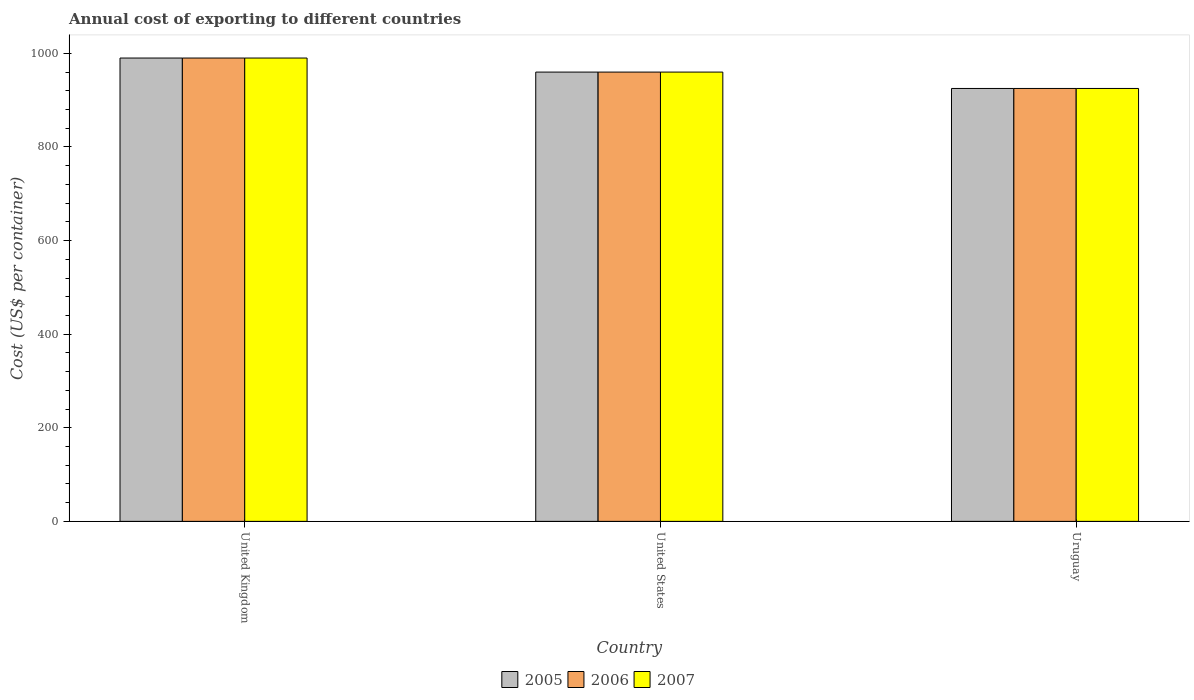How many groups of bars are there?
Offer a very short reply. 3. Are the number of bars per tick equal to the number of legend labels?
Keep it short and to the point. Yes. Are the number of bars on each tick of the X-axis equal?
Provide a short and direct response. Yes. How many bars are there on the 2nd tick from the left?
Make the answer very short. 3. How many bars are there on the 2nd tick from the right?
Your answer should be very brief. 3. What is the label of the 2nd group of bars from the left?
Give a very brief answer. United States. What is the total annual cost of exporting in 2006 in United Kingdom?
Give a very brief answer. 990. Across all countries, what is the maximum total annual cost of exporting in 2007?
Keep it short and to the point. 990. Across all countries, what is the minimum total annual cost of exporting in 2005?
Offer a terse response. 925. In which country was the total annual cost of exporting in 2007 minimum?
Offer a very short reply. Uruguay. What is the total total annual cost of exporting in 2005 in the graph?
Ensure brevity in your answer.  2875. What is the difference between the total annual cost of exporting in 2007 in United Kingdom and that in Uruguay?
Provide a succinct answer. 65. What is the difference between the total annual cost of exporting in 2007 in United States and the total annual cost of exporting in 2005 in United Kingdom?
Give a very brief answer. -30. What is the average total annual cost of exporting in 2005 per country?
Your answer should be compact. 958.33. What is the difference between the total annual cost of exporting of/in 2006 and total annual cost of exporting of/in 2005 in United Kingdom?
Your answer should be very brief. 0. What is the ratio of the total annual cost of exporting in 2006 in United Kingdom to that in United States?
Your answer should be very brief. 1.03. What is the difference between the highest and the second highest total annual cost of exporting in 2005?
Offer a terse response. 35. What is the difference between the highest and the lowest total annual cost of exporting in 2007?
Provide a succinct answer. 65. In how many countries, is the total annual cost of exporting in 2005 greater than the average total annual cost of exporting in 2005 taken over all countries?
Provide a short and direct response. 2. Is the sum of the total annual cost of exporting in 2006 in United States and Uruguay greater than the maximum total annual cost of exporting in 2007 across all countries?
Your response must be concise. Yes. What does the 3rd bar from the left in United Kingdom represents?
Your answer should be compact. 2007. What does the 2nd bar from the right in Uruguay represents?
Your answer should be very brief. 2006. How many bars are there?
Offer a terse response. 9. Are the values on the major ticks of Y-axis written in scientific E-notation?
Your answer should be very brief. No. Does the graph contain grids?
Offer a very short reply. No. How many legend labels are there?
Provide a short and direct response. 3. What is the title of the graph?
Your answer should be compact. Annual cost of exporting to different countries. Does "2005" appear as one of the legend labels in the graph?
Offer a terse response. Yes. What is the label or title of the Y-axis?
Keep it short and to the point. Cost (US$ per container). What is the Cost (US$ per container) of 2005 in United Kingdom?
Provide a succinct answer. 990. What is the Cost (US$ per container) of 2006 in United Kingdom?
Keep it short and to the point. 990. What is the Cost (US$ per container) of 2007 in United Kingdom?
Make the answer very short. 990. What is the Cost (US$ per container) of 2005 in United States?
Keep it short and to the point. 960. What is the Cost (US$ per container) in 2006 in United States?
Provide a succinct answer. 960. What is the Cost (US$ per container) of 2007 in United States?
Your response must be concise. 960. What is the Cost (US$ per container) in 2005 in Uruguay?
Ensure brevity in your answer.  925. What is the Cost (US$ per container) of 2006 in Uruguay?
Your answer should be compact. 925. What is the Cost (US$ per container) in 2007 in Uruguay?
Make the answer very short. 925. Across all countries, what is the maximum Cost (US$ per container) of 2005?
Offer a very short reply. 990. Across all countries, what is the maximum Cost (US$ per container) in 2006?
Provide a short and direct response. 990. Across all countries, what is the maximum Cost (US$ per container) of 2007?
Offer a very short reply. 990. Across all countries, what is the minimum Cost (US$ per container) in 2005?
Your answer should be very brief. 925. Across all countries, what is the minimum Cost (US$ per container) in 2006?
Offer a terse response. 925. Across all countries, what is the minimum Cost (US$ per container) of 2007?
Make the answer very short. 925. What is the total Cost (US$ per container) of 2005 in the graph?
Make the answer very short. 2875. What is the total Cost (US$ per container) in 2006 in the graph?
Offer a terse response. 2875. What is the total Cost (US$ per container) in 2007 in the graph?
Give a very brief answer. 2875. What is the difference between the Cost (US$ per container) in 2006 in United Kingdom and that in United States?
Provide a succinct answer. 30. What is the difference between the Cost (US$ per container) in 2005 in United Kingdom and that in Uruguay?
Offer a very short reply. 65. What is the difference between the Cost (US$ per container) in 2006 in United States and that in Uruguay?
Your response must be concise. 35. What is the difference between the Cost (US$ per container) in 2007 in United States and that in Uruguay?
Offer a terse response. 35. What is the difference between the Cost (US$ per container) of 2005 in United Kingdom and the Cost (US$ per container) of 2006 in United States?
Keep it short and to the point. 30. What is the difference between the Cost (US$ per container) in 2005 in United Kingdom and the Cost (US$ per container) in 2007 in Uruguay?
Keep it short and to the point. 65. What is the difference between the Cost (US$ per container) in 2006 in United Kingdom and the Cost (US$ per container) in 2007 in Uruguay?
Make the answer very short. 65. What is the difference between the Cost (US$ per container) in 2005 in United States and the Cost (US$ per container) in 2007 in Uruguay?
Give a very brief answer. 35. What is the difference between the Cost (US$ per container) in 2006 in United States and the Cost (US$ per container) in 2007 in Uruguay?
Your response must be concise. 35. What is the average Cost (US$ per container) in 2005 per country?
Your answer should be compact. 958.33. What is the average Cost (US$ per container) of 2006 per country?
Your response must be concise. 958.33. What is the average Cost (US$ per container) of 2007 per country?
Offer a terse response. 958.33. What is the difference between the Cost (US$ per container) of 2005 and Cost (US$ per container) of 2006 in United Kingdom?
Give a very brief answer. 0. What is the difference between the Cost (US$ per container) in 2005 and Cost (US$ per container) in 2007 in United Kingdom?
Offer a terse response. 0. What is the difference between the Cost (US$ per container) of 2005 and Cost (US$ per container) of 2006 in United States?
Keep it short and to the point. 0. What is the ratio of the Cost (US$ per container) in 2005 in United Kingdom to that in United States?
Ensure brevity in your answer.  1.03. What is the ratio of the Cost (US$ per container) in 2006 in United Kingdom to that in United States?
Provide a succinct answer. 1.03. What is the ratio of the Cost (US$ per container) of 2007 in United Kingdom to that in United States?
Offer a terse response. 1.03. What is the ratio of the Cost (US$ per container) in 2005 in United Kingdom to that in Uruguay?
Offer a very short reply. 1.07. What is the ratio of the Cost (US$ per container) of 2006 in United Kingdom to that in Uruguay?
Keep it short and to the point. 1.07. What is the ratio of the Cost (US$ per container) of 2007 in United Kingdom to that in Uruguay?
Provide a succinct answer. 1.07. What is the ratio of the Cost (US$ per container) in 2005 in United States to that in Uruguay?
Make the answer very short. 1.04. What is the ratio of the Cost (US$ per container) of 2006 in United States to that in Uruguay?
Make the answer very short. 1.04. What is the ratio of the Cost (US$ per container) of 2007 in United States to that in Uruguay?
Provide a succinct answer. 1.04. What is the difference between the highest and the second highest Cost (US$ per container) in 2005?
Your answer should be compact. 30. What is the difference between the highest and the second highest Cost (US$ per container) in 2007?
Keep it short and to the point. 30. What is the difference between the highest and the lowest Cost (US$ per container) in 2005?
Provide a succinct answer. 65. What is the difference between the highest and the lowest Cost (US$ per container) in 2006?
Provide a succinct answer. 65. 